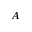<formula> <loc_0><loc_0><loc_500><loc_500>A</formula> 